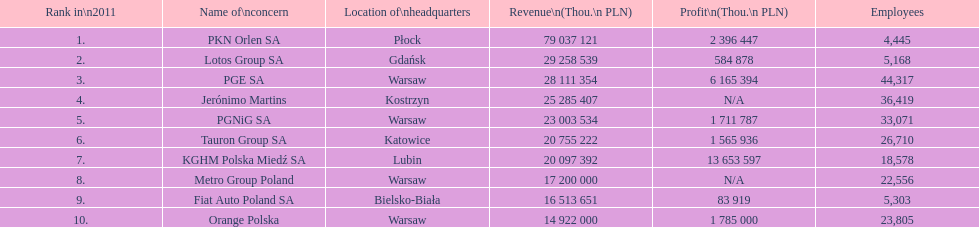What are the titles of all the worries? PKN Orlen SA, Lotos Group SA, PGE SA, Jerónimo Martins, PGNiG SA, Tauron Group SA, KGHM Polska Miedź SA, Metro Group Poland, Fiat Auto Poland SA, Orange Polska. How many workers does pgnig sa employ? 33,071. 